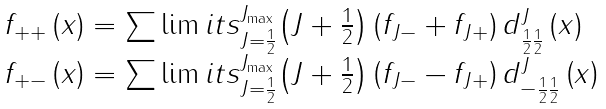Convert formula to latex. <formula><loc_0><loc_0><loc_500><loc_500>\begin{array} { l } f _ { + + } \left ( x \right ) = \sum \lim i t s _ { J = \frac { 1 } { 2 } } ^ { J _ { \max } } { \left ( { J + \frac { 1 } { 2 } } \right ) } \left ( { f _ { J - } + f _ { J + } } \right ) d _ { \frac { 1 } { 2 } \frac { 1 } { 2 } } ^ { J } \left ( x \right ) \\ f _ { + - } \left ( x \right ) = \sum \lim i t s _ { J = \frac { 1 } { 2 } } ^ { J _ { \max } } { \left ( { J + \frac { 1 } { 2 } } \right ) } \left ( { f _ { J - } - f _ { J + } } \right ) d _ { - \frac { 1 } { 2 } \frac { 1 } { 2 } } ^ { J } \left ( x \right ) \\ \end{array}</formula> 